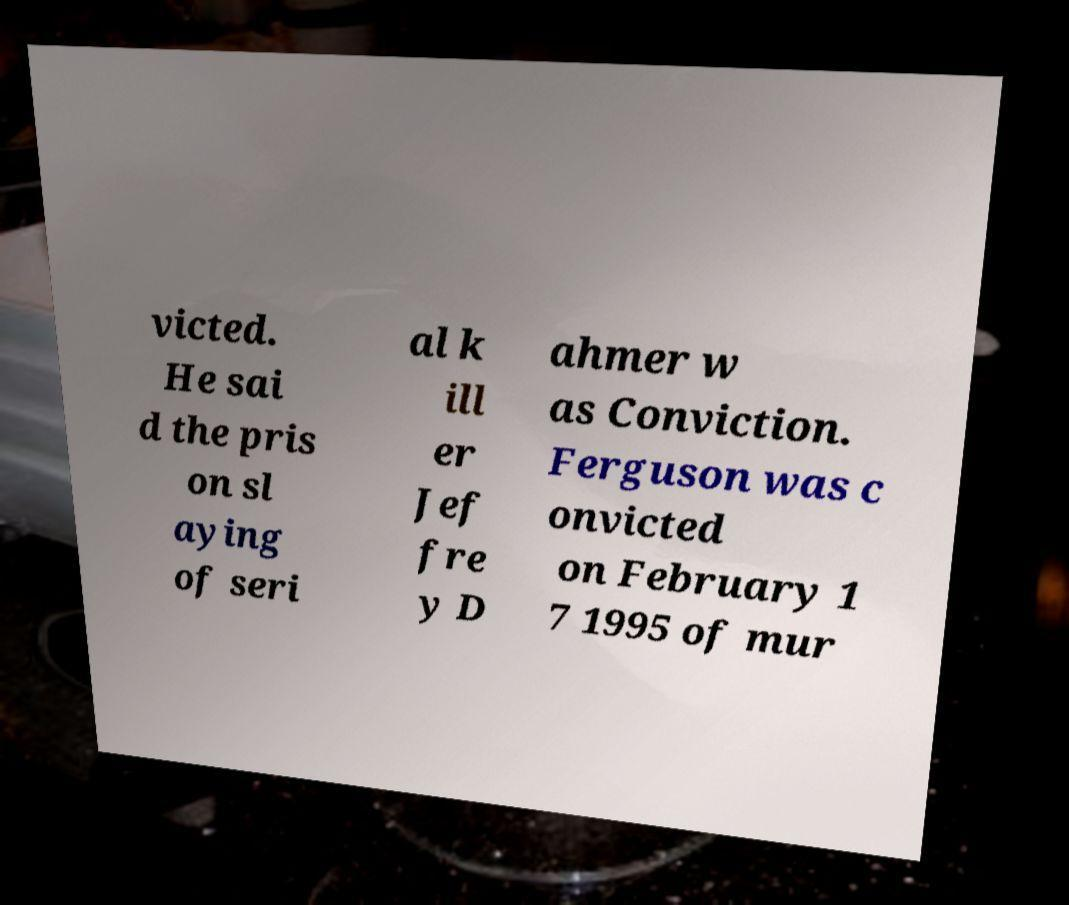There's text embedded in this image that I need extracted. Can you transcribe it verbatim? victed. He sai d the pris on sl aying of seri al k ill er Jef fre y D ahmer w as Conviction. Ferguson was c onvicted on February 1 7 1995 of mur 